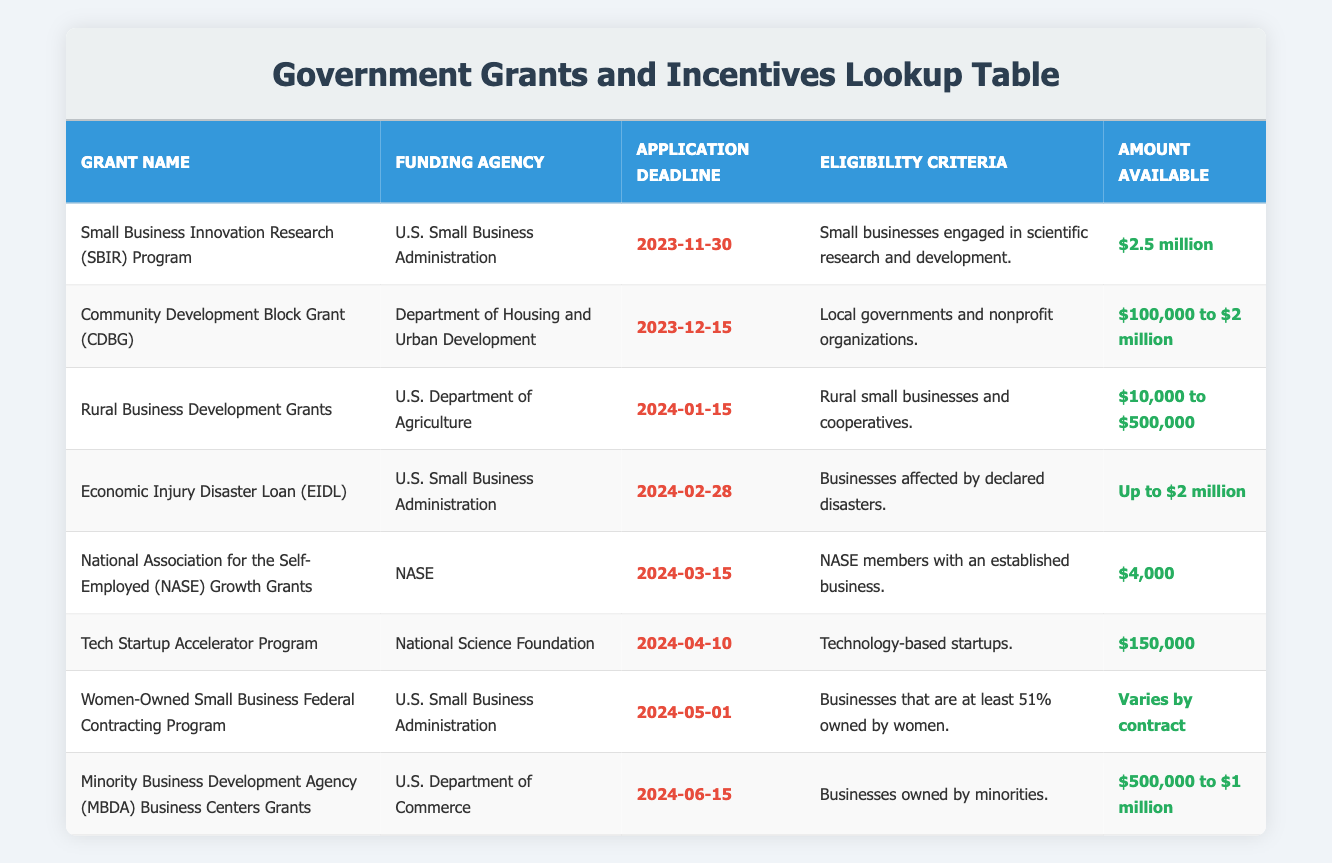What is the application deadline for the Small Business Innovation Research (SBIR) Program? The table lists the application deadline for the Small Business Innovation Research (SBIR) Program as November 30, 2023, in the corresponding row under the "Application Deadline" column.
Answer: November 30, 2023 How much funding is available for the Community Development Block Grant (CDBG)? In the table, the amount available for the Community Development Block Grant (CDBG) is specified as "$100,000 to $2 million" in the "Amount Available" column of the relevant row.
Answer: $100,000 to $2 million Are the eligibility criteria for the Economic Injury Disaster Loan (EIDL) only for businesses affected by disasters? The "Eligibility Criteria" for the Economic Injury Disaster Loan (EIDL) states that it is for "Businesses affected by declared disasters," confirming the eligibility criteria only include those impacted by disasters.
Answer: Yes Which grant has the latest application deadline and what is it? To find the latest deadline, we scan the "Application Deadline" column for the latest date. The latest application deadline from the list is June 15, 2024, for the Minority Business Development Agency (MBDA) Business Centers Grants.
Answer: June 15, 2024 for the MBDA Business Centers Grants What is the average amount available across all grants listed? We extract the amounts available from each grant, treating ranges as their averages: SBIR ($2.5 million = 2500), CDBG ($1.05 million = 1050, median of $100,000 and $2 million), Rural Business Development Grants ($255,000 = average of $10,000 and $500,000), EIDL ($2 million = 2000), NASE ($4,000 = 4), Tech Startup Accelerator ($150,000), Women-Owned Program (average = variable), MBDA ($750,000 average of $500,000 and $1 million). Summing these up gives approximately $4,421,000 divided by 8 grants yields an average of about $552,625.
Answer: $552,625 Is the National Association for the Self-Employed (NASE) Growth Grants amount more than $5,000? The "Amount Available" for the NASE Growth Grants is stated as "$4,000," which is less than $5,000, so this is a false statement.
Answer: No 